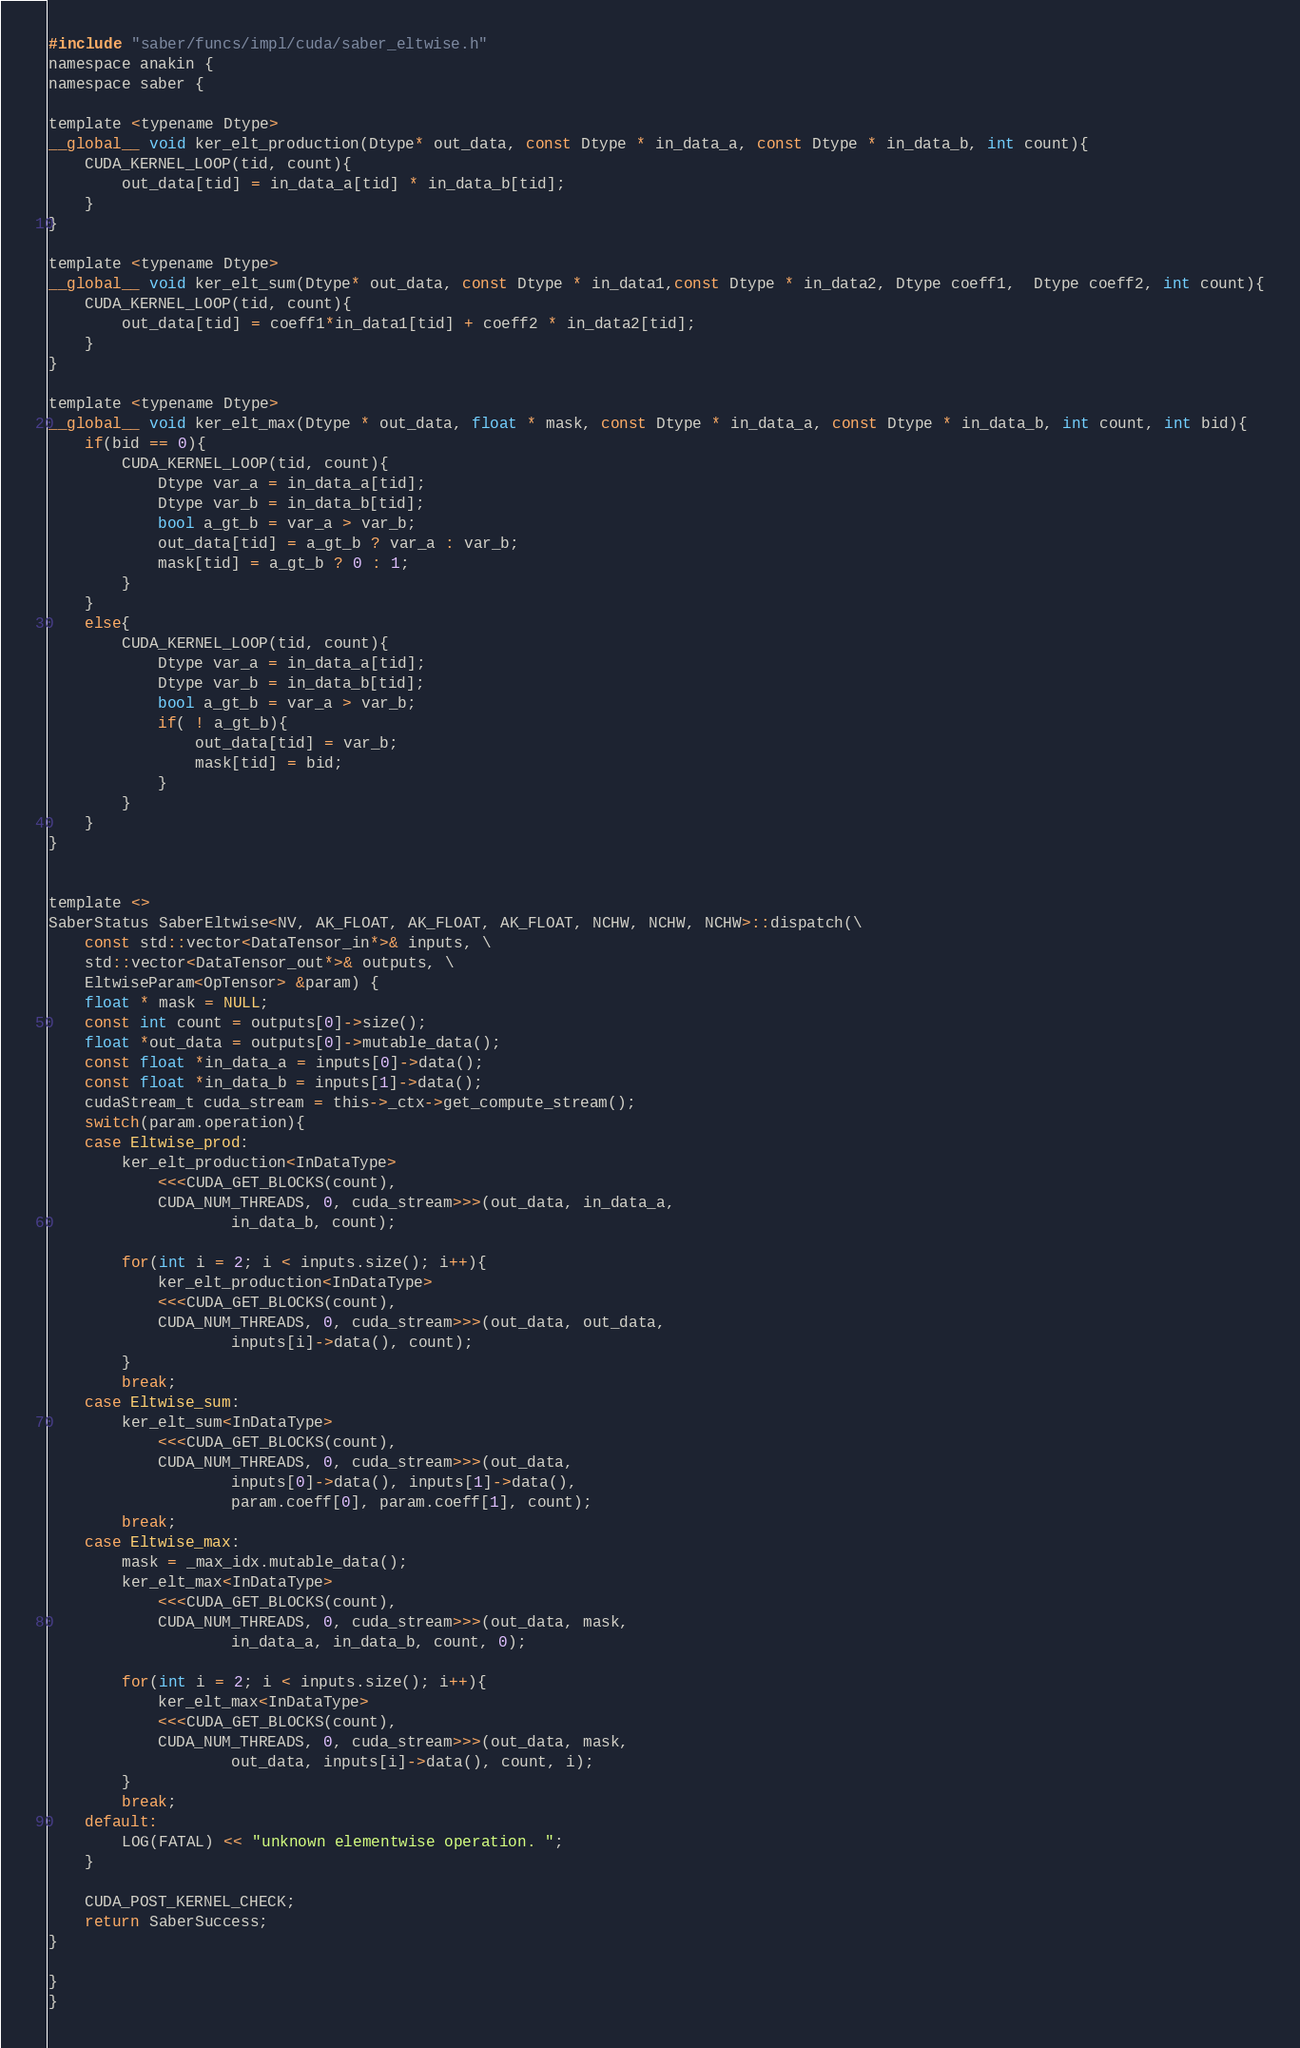<code> <loc_0><loc_0><loc_500><loc_500><_Cuda_>#include "saber/funcs/impl/cuda/saber_eltwise.h"
namespace anakin {
namespace saber {

template <typename Dtype>
__global__ void ker_elt_production(Dtype* out_data, const Dtype * in_data_a, const Dtype * in_data_b, int count){
    CUDA_KERNEL_LOOP(tid, count){
        out_data[tid] = in_data_a[tid] * in_data_b[tid];
    }
}

template <typename Dtype>
__global__ void ker_elt_sum(Dtype* out_data, const Dtype * in_data1,const Dtype * in_data2, Dtype coeff1,  Dtype coeff2, int count){
    CUDA_KERNEL_LOOP(tid, count){
        out_data[tid] = coeff1*in_data1[tid] + coeff2 * in_data2[tid];
    }
}

template <typename Dtype>
__global__ void ker_elt_max(Dtype * out_data, float * mask, const Dtype * in_data_a, const Dtype * in_data_b, int count, int bid){
    if(bid == 0){
        CUDA_KERNEL_LOOP(tid, count){
            Dtype var_a = in_data_a[tid];
            Dtype var_b = in_data_b[tid];
            bool a_gt_b = var_a > var_b;
            out_data[tid] = a_gt_b ? var_a : var_b;
            mask[tid] = a_gt_b ? 0 : 1;
        }
    }
    else{
        CUDA_KERNEL_LOOP(tid, count){
            Dtype var_a = in_data_a[tid];
            Dtype var_b = in_data_b[tid];
            bool a_gt_b = var_a > var_b;
            if( ! a_gt_b){
                out_data[tid] = var_b;
                mask[tid] = bid;
            }
        }
    }
}


template <>
SaberStatus SaberEltwise<NV, AK_FLOAT, AK_FLOAT, AK_FLOAT, NCHW, NCHW, NCHW>::dispatch(\
    const std::vector<DataTensor_in*>& inputs, \
    std::vector<DataTensor_out*>& outputs, \
    EltwiseParam<OpTensor> &param) {
    float * mask = NULL;
    const int count = outputs[0]->size();
    float *out_data = outputs[0]->mutable_data();
    const float *in_data_a = inputs[0]->data();
	const float *in_data_b = inputs[1]->data();
    cudaStream_t cuda_stream = this->_ctx->get_compute_stream();
    switch(param.operation){
	case Eltwise_prod:
		ker_elt_production<InDataType>
            <<<CUDA_GET_BLOCKS(count),
            CUDA_NUM_THREADS, 0, cuda_stream>>>(out_data, in_data_a,
                    in_data_b, count);

		for(int i = 2; i < inputs.size(); i++){
			ker_elt_production<InDataType>
            <<<CUDA_GET_BLOCKS(count),
            CUDA_NUM_THREADS, 0, cuda_stream>>>(out_data, out_data,
                    inputs[i]->data(), count);
		}
		break;
	case Eltwise_sum:
		ker_elt_sum<InDataType>
            <<<CUDA_GET_BLOCKS(count),
            CUDA_NUM_THREADS, 0, cuda_stream>>>(out_data,
                    inputs[0]->data(), inputs[1]->data(),
                    param.coeff[0], param.coeff[1], count);
		break;
	case Eltwise_max:
		mask = _max_idx.mutable_data();
		ker_elt_max<InDataType>
            <<<CUDA_GET_BLOCKS(count),
            CUDA_NUM_THREADS, 0, cuda_stream>>>(out_data, mask,
                    in_data_a, in_data_b, count, 0);

		for(int i = 2; i < inputs.size(); i++){
			ker_elt_max<InDataType>
            <<<CUDA_GET_BLOCKS(count),
            CUDA_NUM_THREADS, 0, cuda_stream>>>(out_data, mask,
                    out_data, inputs[i]->data(), count, i);
		}
		break;
	default:
		LOG(FATAL) << "unknown elementwise operation. ";
	}

    CUDA_POST_KERNEL_CHECK;
    return SaberSuccess;
}

}
}</code> 